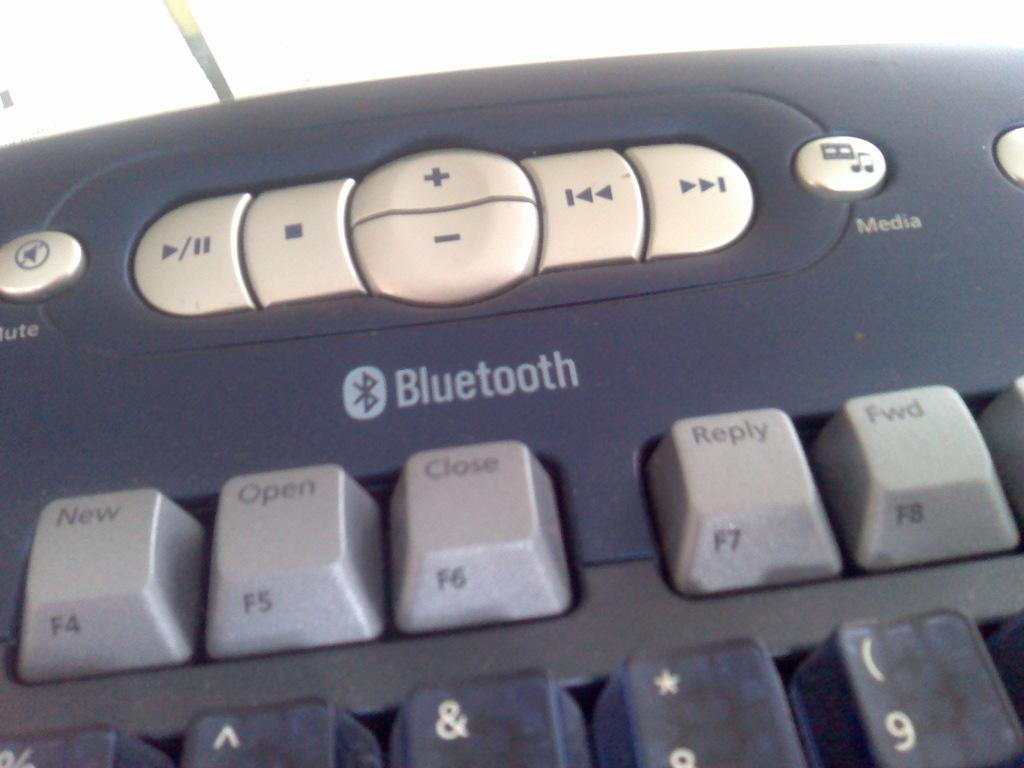Provide a one-sentence caption for the provided image. A bluetooth keyboard is being used to type. 